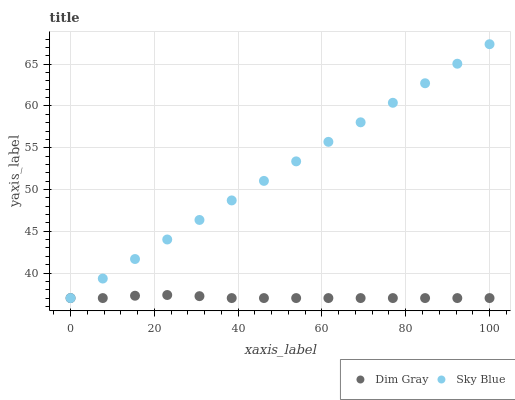Does Dim Gray have the minimum area under the curve?
Answer yes or no. Yes. Does Sky Blue have the maximum area under the curve?
Answer yes or no. Yes. Does Dim Gray have the maximum area under the curve?
Answer yes or no. No. Is Sky Blue the smoothest?
Answer yes or no. Yes. Is Dim Gray the roughest?
Answer yes or no. Yes. Is Dim Gray the smoothest?
Answer yes or no. No. Does Sky Blue have the lowest value?
Answer yes or no. Yes. Does Sky Blue have the highest value?
Answer yes or no. Yes. Does Dim Gray have the highest value?
Answer yes or no. No. Does Dim Gray intersect Sky Blue?
Answer yes or no. Yes. Is Dim Gray less than Sky Blue?
Answer yes or no. No. Is Dim Gray greater than Sky Blue?
Answer yes or no. No. 